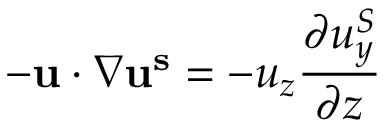Convert formula to latex. <formula><loc_0><loc_0><loc_500><loc_500>- u \cdot \nabla u ^ { s } = - u _ { z } \frac { \partial u _ { y } ^ { S } } { \partial z }</formula> 